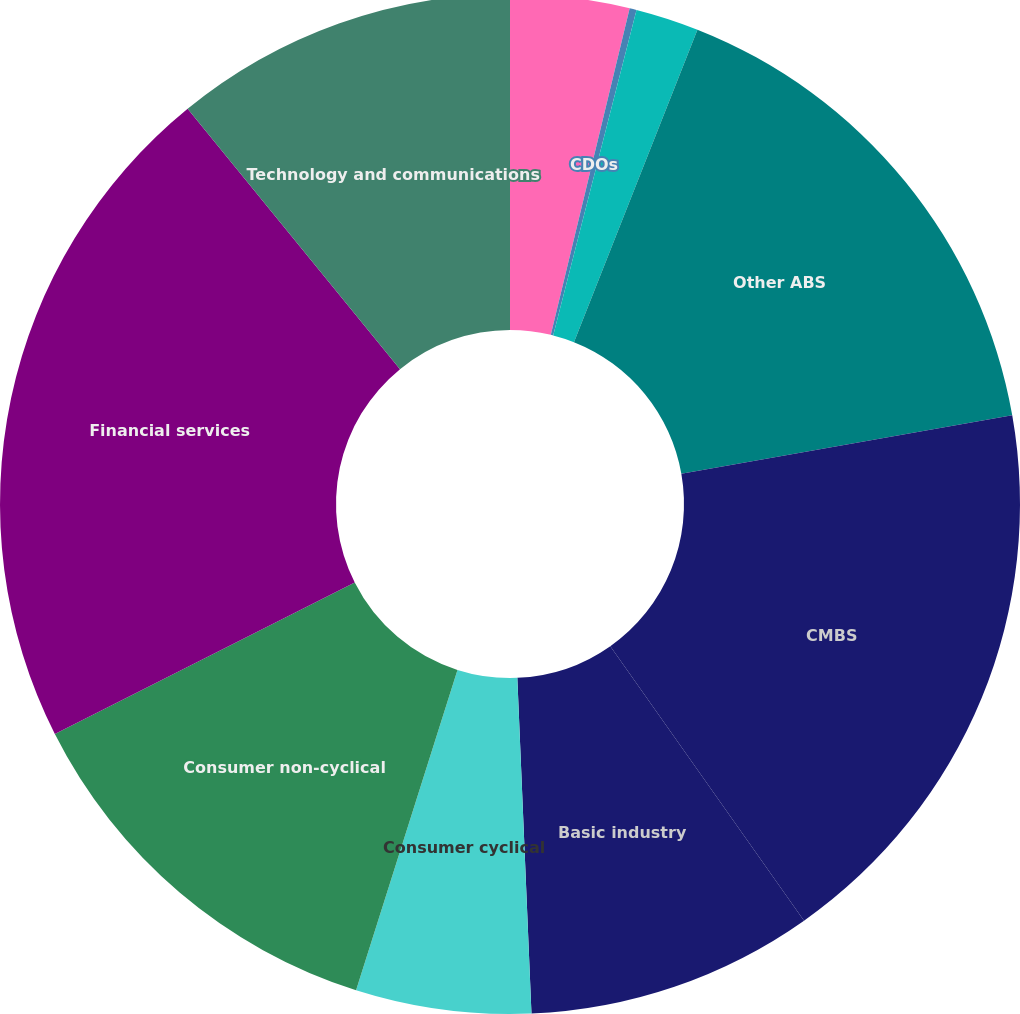Convert chart. <chart><loc_0><loc_0><loc_500><loc_500><pie_chart><fcel>Aircraft lease receivables<fcel>CDOs<fcel>Credit card receivables<fcel>Other ABS<fcel>CMBS<fcel>Basic industry<fcel>Consumer cyclical<fcel>Consumer non-cyclical<fcel>Financial services<fcel>Technology and communications<nl><fcel>3.77%<fcel>0.22%<fcel>2.0%<fcel>16.23%<fcel>18.0%<fcel>9.11%<fcel>5.55%<fcel>12.67%<fcel>21.56%<fcel>10.89%<nl></chart> 